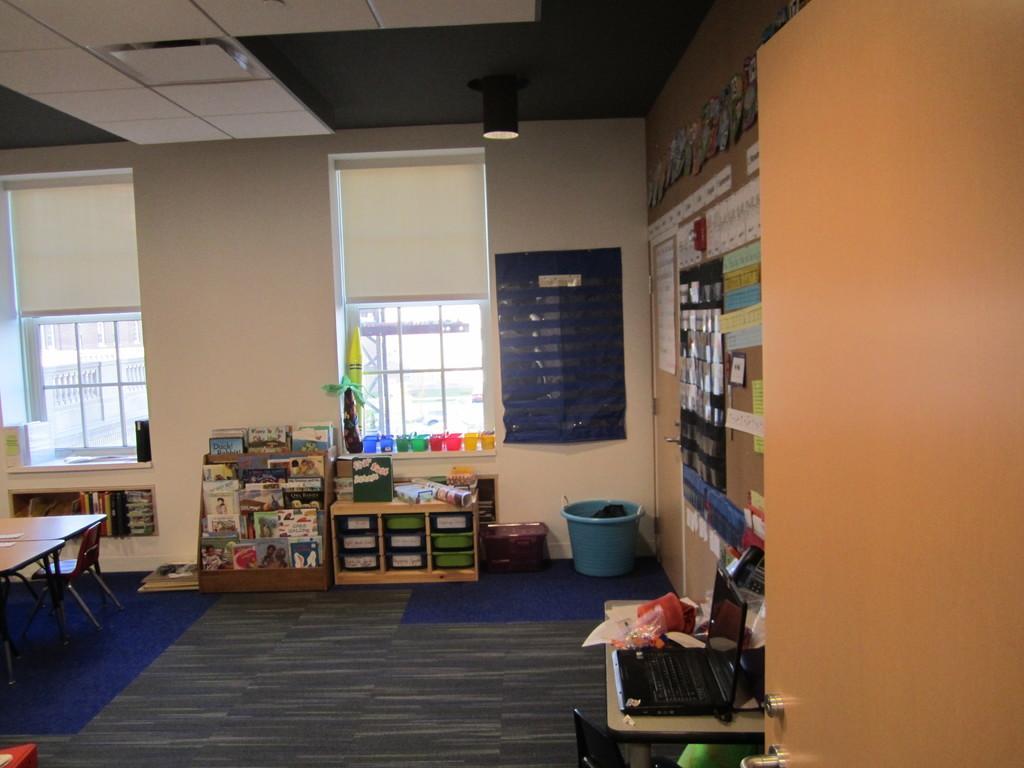Please provide a concise description of this image. In this picture we can see tables, chair, carpets, tub, racks on the floor, laptop, books, posters on the wall, ceiling, windows and some objects and from windows we can see rods, railing. 